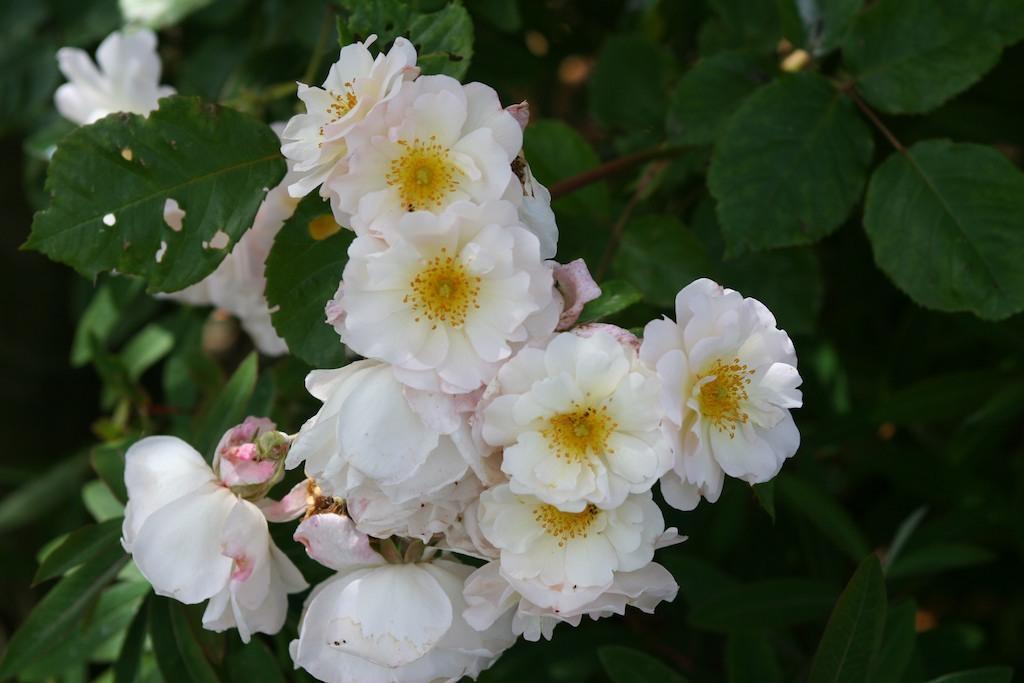Can you describe this image briefly? In this picture, we see a plant which has flowers. These flowers are in white color. In the background, we see the plants or trees. 